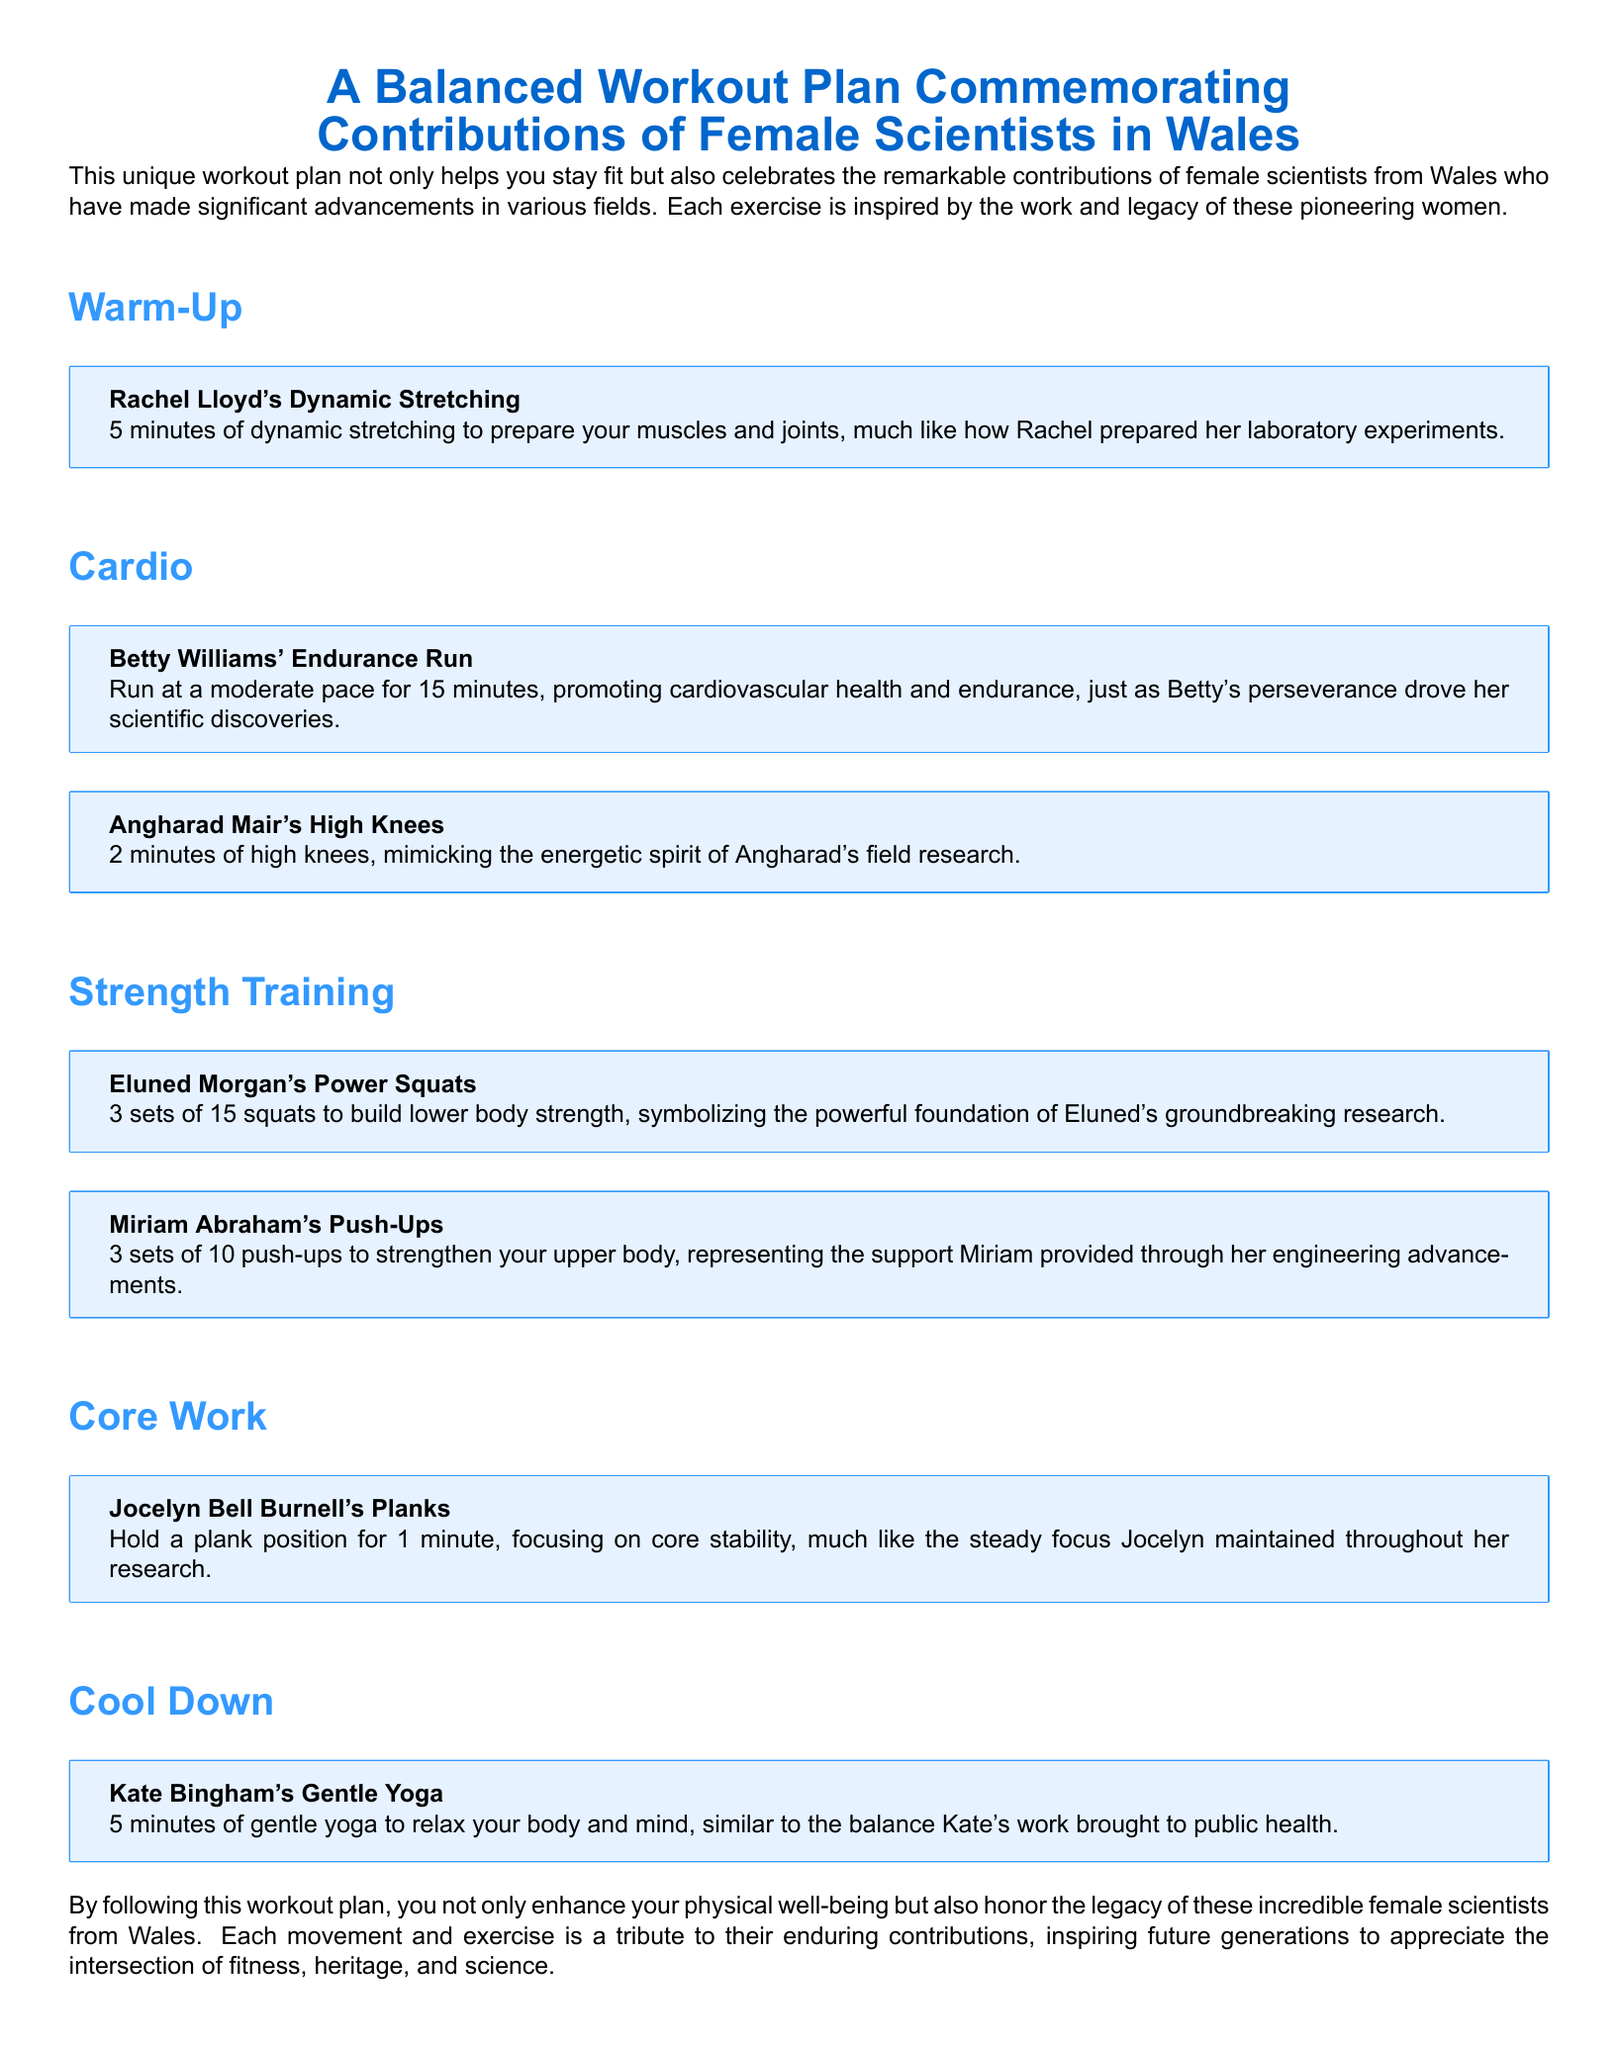What is the title of the workout plan? The title of the workout plan is "A Balanced Workout Plan Commemorating Contributions of Female Scientists in Wales."
Answer: A Balanced Workout Plan Commemorating Contributions of Female Scientists in Wales Who inspired the dynamic stretching activity? The activity of dynamic stretching is inspired by Rachel Lloyd.
Answer: Rachel Lloyd How long should the endurance run be? The endurance run activity lasts for 15 minutes.
Answer: 15 minutes What are the two exercises included in the core workout? The core workout includes planks inspired by Jocelyn Bell Burnell.
Answer: Planks How many squats are performed in the strength training section? In the strength training section, 3 sets of 15 squats are performed.
Answer: 3 sets of 15 Which scientist's work is honored through the gentle yoga activity? The gentle yoga activity honors Kate Bingham.
Answer: Kate Bingham What is the total number of exercises listed in the workout plan? There are a total of 6 exercises listed in the workout plan.
Answer: 6 What type of workout is the document designed for? The document is designed for a balanced workout plan.
Answer: Balanced workout plan 